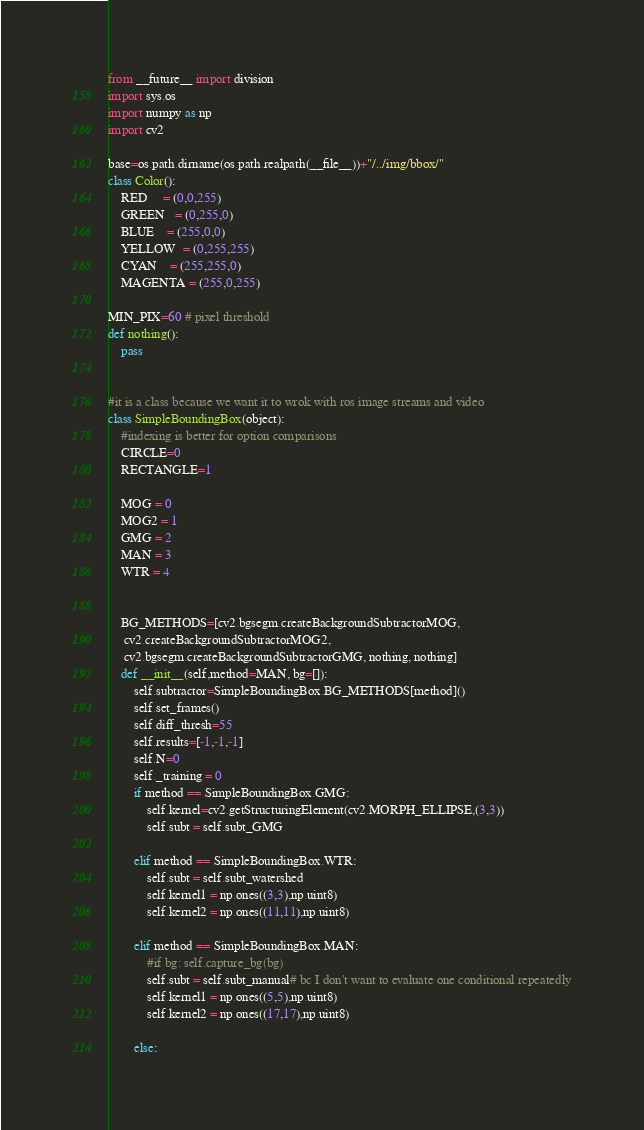Convert code to text. <code><loc_0><loc_0><loc_500><loc_500><_Python_>from __future__ import division
import sys,os
import numpy as np
import cv2

base=os.path.dirname(os.path.realpath(__file__))+"/../img/bbox/"
class Color():
    RED     = (0,0,255)
    GREEN   = (0,255,0)
    BLUE    = (255,0,0)
    YELLOW  = (0,255,255)
    CYAN    = (255,255,0)
    MAGENTA = (255,0,255)

MIN_PIX=60 # pixel threshold
def nothing():
    pass


#it is a class because we want it to wrok with ros image streams and video
class SimpleBoundingBox(object):
    #indexing is better for option comparisons
    CIRCLE=0
    RECTANGLE=1

    MOG = 0
    MOG2 = 1
    GMG = 2
    MAN = 3
    WTR = 4


    BG_METHODS=[cv2.bgsegm.createBackgroundSubtractorMOG,
     cv2.createBackgroundSubtractorMOG2,
     cv2.bgsegm.createBackgroundSubtractorGMG, nothing, nothing]
    def __init__(self,method=MAN, bg=[]):
        self.subtractor=SimpleBoundingBox.BG_METHODS[method]()
        self.set_frames()
        self.diff_thresh=55
        self.results=[-1,-1,-1]
        self.N=0
        self._training = 0
        if method == SimpleBoundingBox.GMG:
            self.kernel=cv2.getStructuringElement(cv2.MORPH_ELLIPSE,(3,3))
            self.subt = self.subt_GMG

        elif method == SimpleBoundingBox.WTR:
            self.subt = self.subt_watershed
            self.kernel1 = np.ones((3,3),np.uint8)
            self.kernel2 = np.ones((11,11),np.uint8)

        elif method == SimpleBoundingBox.MAN:
            #if bg: self.capture_bg(bg)
            self.subt = self.subt_manual# bc I don't want to evaluate one conditional repeatedly
            self.kernel1 = np.ones((5,5),np.uint8)
            self.kernel2 = np.ones((17,17),np.uint8)

        else:</code> 